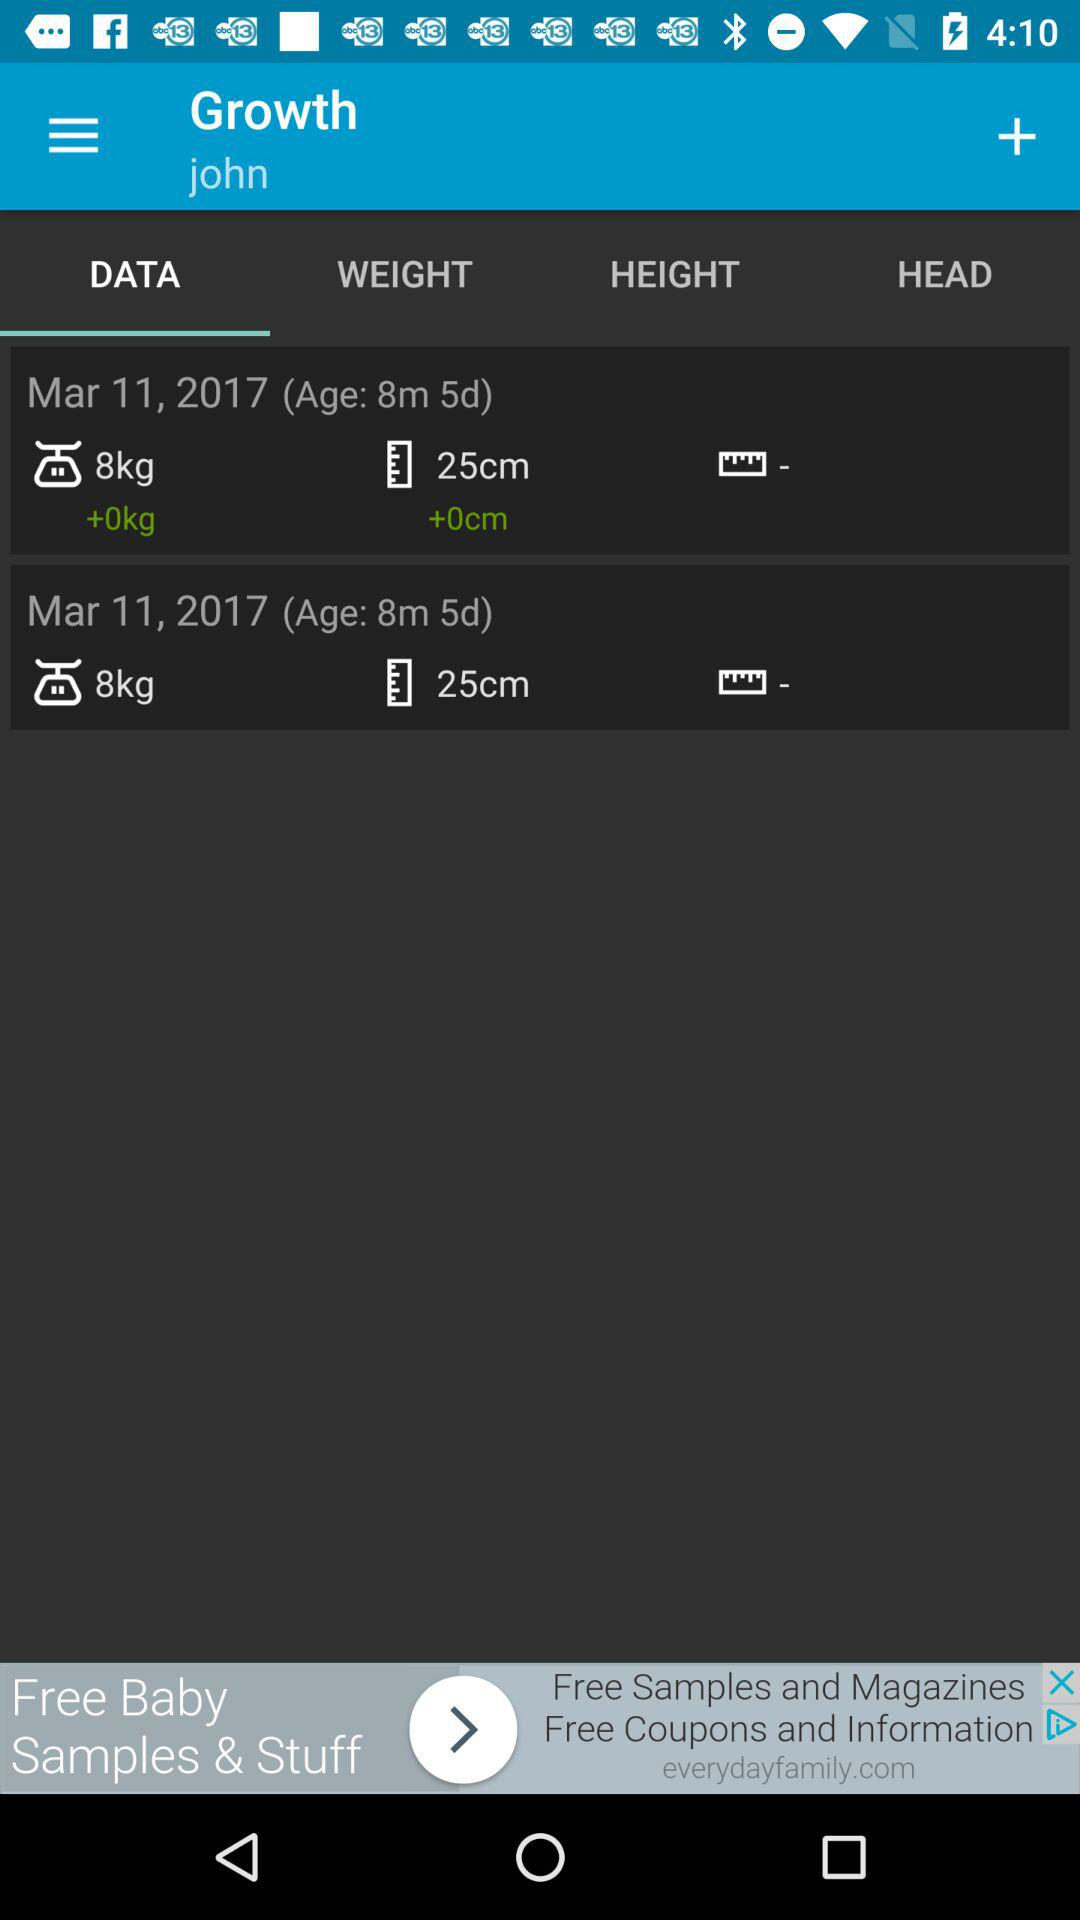What is the height on march 11,2017?
When the provided information is insufficient, respond with <no answer>. <no answer> 